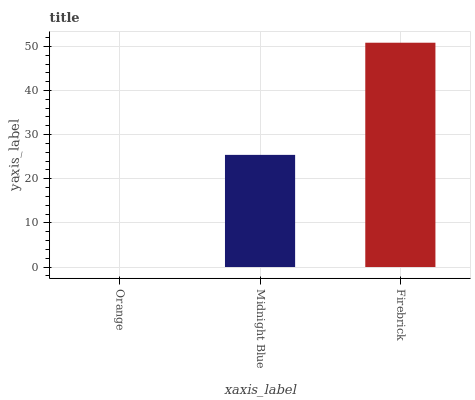Is Orange the minimum?
Answer yes or no. Yes. Is Firebrick the maximum?
Answer yes or no. Yes. Is Midnight Blue the minimum?
Answer yes or no. No. Is Midnight Blue the maximum?
Answer yes or no. No. Is Midnight Blue greater than Orange?
Answer yes or no. Yes. Is Orange less than Midnight Blue?
Answer yes or no. Yes. Is Orange greater than Midnight Blue?
Answer yes or no. No. Is Midnight Blue less than Orange?
Answer yes or no. No. Is Midnight Blue the high median?
Answer yes or no. Yes. Is Midnight Blue the low median?
Answer yes or no. Yes. Is Firebrick the high median?
Answer yes or no. No. Is Orange the low median?
Answer yes or no. No. 